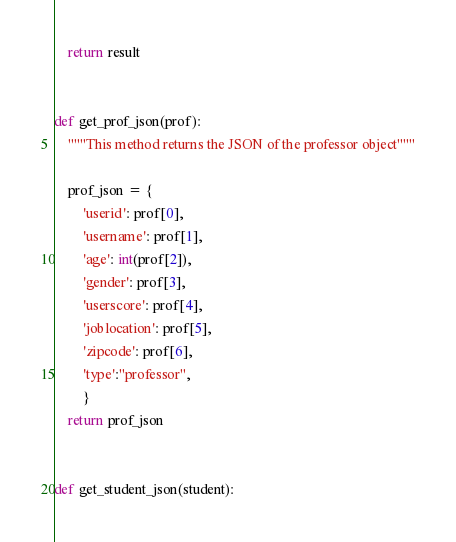<code> <loc_0><loc_0><loc_500><loc_500><_Python_>    return result


def get_prof_json(prof):
    """This method returns the JSON of the professor object"""

    prof_json = {
        'userid': prof[0],
        'username': prof[1],
        'age': int(prof[2]),
        'gender': prof[3],
        'userscore': prof[4],
        'joblocation': prof[5],
        'zipcode': prof[6],
        'type':"professor",
        }
    return prof_json


def get_student_json(student):</code> 